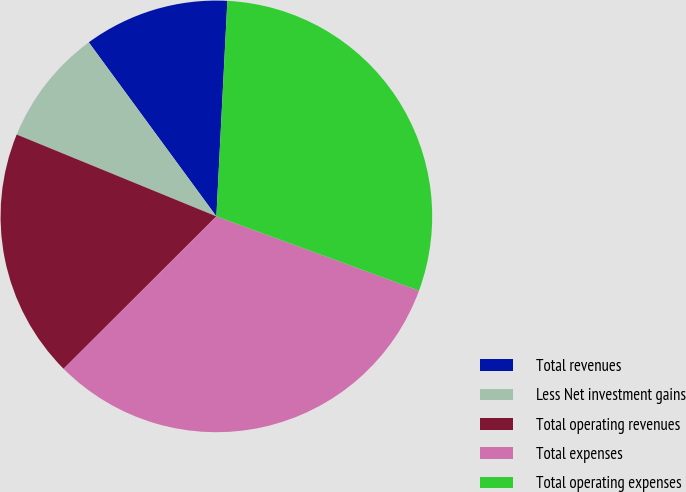Convert chart. <chart><loc_0><loc_0><loc_500><loc_500><pie_chart><fcel>Total revenues<fcel>Less Net investment gains<fcel>Total operating revenues<fcel>Total expenses<fcel>Total operating expenses<nl><fcel>10.88%<fcel>8.74%<fcel>18.67%<fcel>31.93%<fcel>29.78%<nl></chart> 